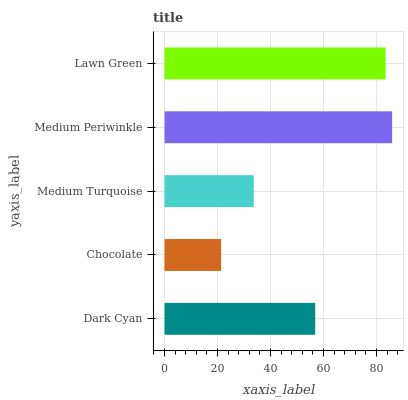Is Chocolate the minimum?
Answer yes or no. Yes. Is Medium Periwinkle the maximum?
Answer yes or no. Yes. Is Medium Turquoise the minimum?
Answer yes or no. No. Is Medium Turquoise the maximum?
Answer yes or no. No. Is Medium Turquoise greater than Chocolate?
Answer yes or no. Yes. Is Chocolate less than Medium Turquoise?
Answer yes or no. Yes. Is Chocolate greater than Medium Turquoise?
Answer yes or no. No. Is Medium Turquoise less than Chocolate?
Answer yes or no. No. Is Dark Cyan the high median?
Answer yes or no. Yes. Is Dark Cyan the low median?
Answer yes or no. Yes. Is Chocolate the high median?
Answer yes or no. No. Is Lawn Green the low median?
Answer yes or no. No. 